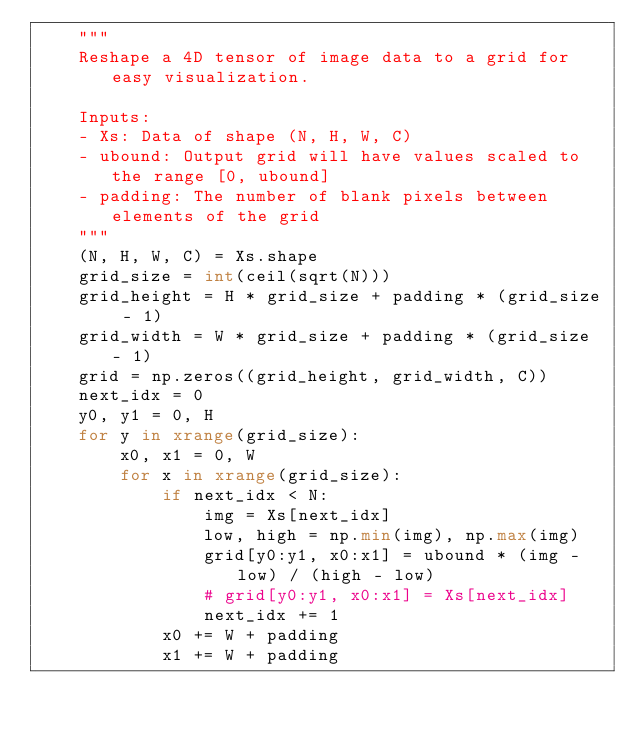Convert code to text. <code><loc_0><loc_0><loc_500><loc_500><_Python_>    """
    Reshape a 4D tensor of image data to a grid for easy visualization.

    Inputs:
    - Xs: Data of shape (N, H, W, C)
    - ubound: Output grid will have values scaled to the range [0, ubound]
    - padding: The number of blank pixels between elements of the grid
    """
    (N, H, W, C) = Xs.shape
    grid_size = int(ceil(sqrt(N)))
    grid_height = H * grid_size + padding * (grid_size - 1)
    grid_width = W * grid_size + padding * (grid_size - 1)
    grid = np.zeros((grid_height, grid_width, C))
    next_idx = 0
    y0, y1 = 0, H
    for y in xrange(grid_size):
        x0, x1 = 0, W
        for x in xrange(grid_size):
            if next_idx < N:
                img = Xs[next_idx]
                low, high = np.min(img), np.max(img)
                grid[y0:y1, x0:x1] = ubound * (img - low) / (high - low)
                # grid[y0:y1, x0:x1] = Xs[next_idx]
                next_idx += 1
            x0 += W + padding
            x1 += W + padding</code> 